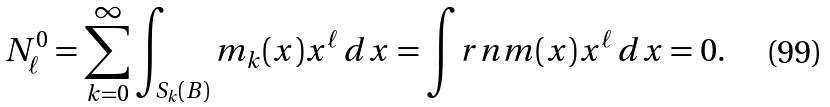Convert formula to latex. <formula><loc_0><loc_0><loc_500><loc_500>N _ { \ell } ^ { 0 } = \sum _ { k = 0 } ^ { \infty } \int _ { S _ { k } ( B ) } m _ { k } ( x ) x ^ { \ell } \, d x = \int _ { \ } r n m ( x ) x ^ { \ell } \, d x = 0 .</formula> 